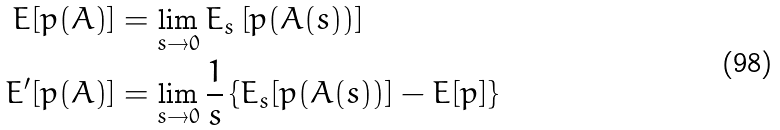Convert formula to latex. <formula><loc_0><loc_0><loc_500><loc_500>E [ p ( A ) ] & = \lim _ { s \to 0 } E _ { s } \left [ p ( A ( s ) ) \right ] \\ E ^ { \prime } [ p ( A ) ] & = \lim _ { s \to 0 } \frac { 1 } { s } \left \{ E _ { s } [ p ( A ( s ) ) ] - E [ p ] \right \}</formula> 